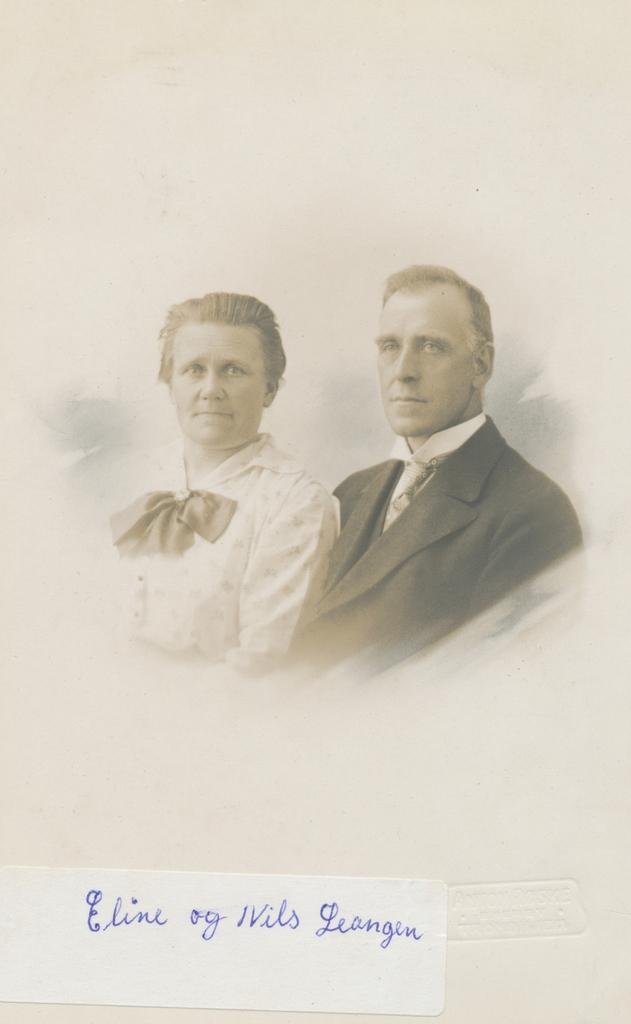What subjects are depicted in the image? There is a picture of a man and a picture of a woman in the image. Can you describe the gender of the subjects in the image? The subjects in the image are a man and a woman. What type of pet can be seen playing with a basin in the image? There is no pet or basin present in the image; it only features pictures of a man and a woman. How many times does the woman smash the man's face in the image? There is no action of smashing in the image; it only shows pictures of a man and a woman. 